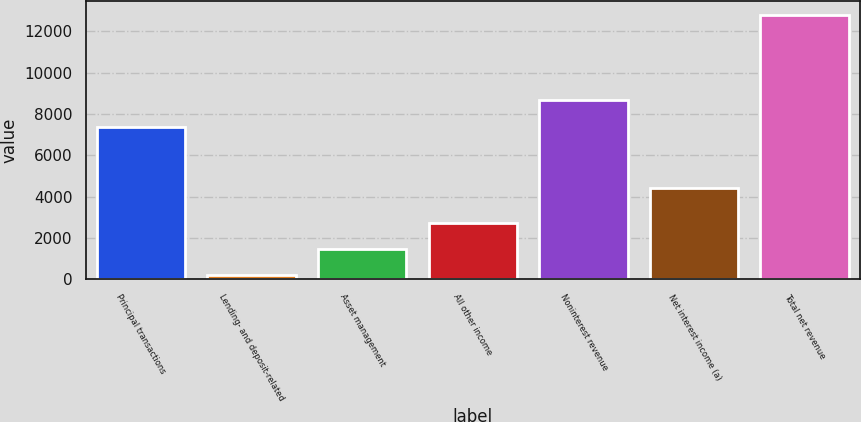<chart> <loc_0><loc_0><loc_500><loc_500><bar_chart><fcel>Principal transactions<fcel>Lending- and deposit-related<fcel>Asset management<fcel>All other income<fcel>Noninterest revenue<fcel>Net interest income (a)<fcel>Total net revenue<nl><fcel>7393<fcel>191<fcel>1453.1<fcel>2715.2<fcel>8655.1<fcel>4402<fcel>12812<nl></chart> 